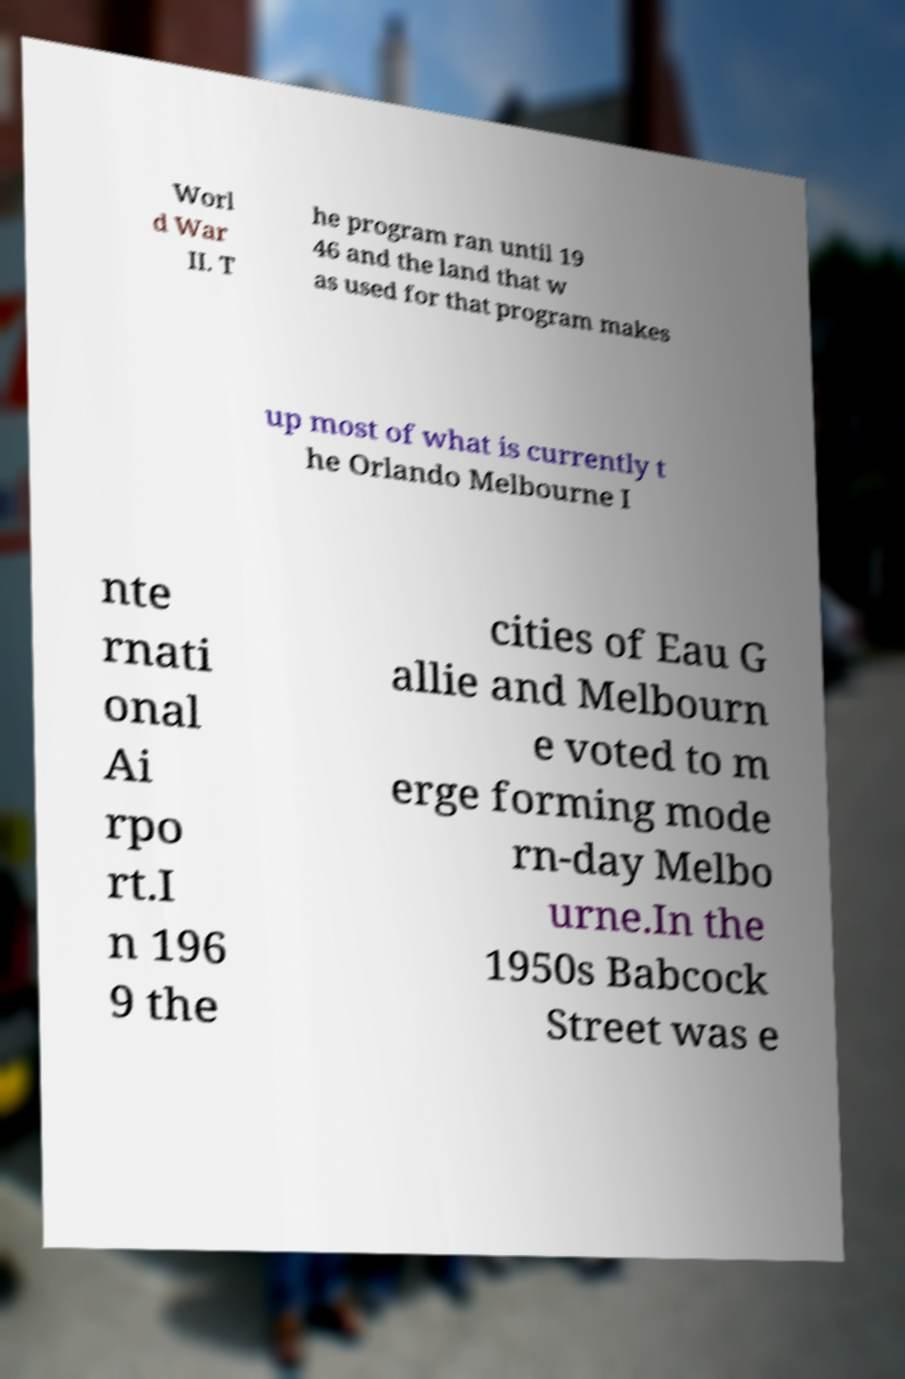Please identify and transcribe the text found in this image. Worl d War II. T he program ran until 19 46 and the land that w as used for that program makes up most of what is currently t he Orlando Melbourne I nte rnati onal Ai rpo rt.I n 196 9 the cities of Eau G allie and Melbourn e voted to m erge forming mode rn-day Melbo urne.In the 1950s Babcock Street was e 